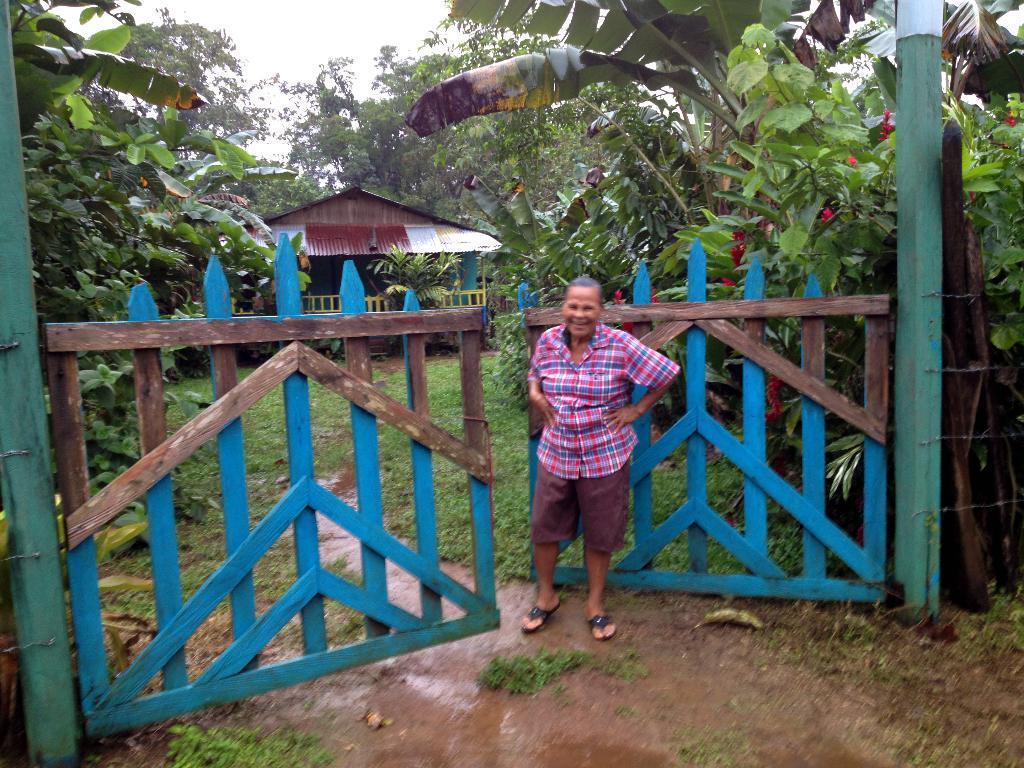Could you give a brief overview of what you see in this image? This image consists of trees in the middle. There is a gate in the middle. There is a person standing near the gate. There is sky at the top. There is something like a hut in the middle. 